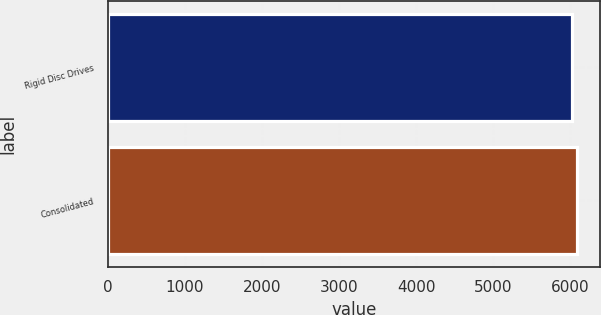Convert chart. <chart><loc_0><loc_0><loc_500><loc_500><bar_chart><fcel>Rigid Disc Drives<fcel>Consolidated<nl><fcel>6023<fcel>6087<nl></chart> 